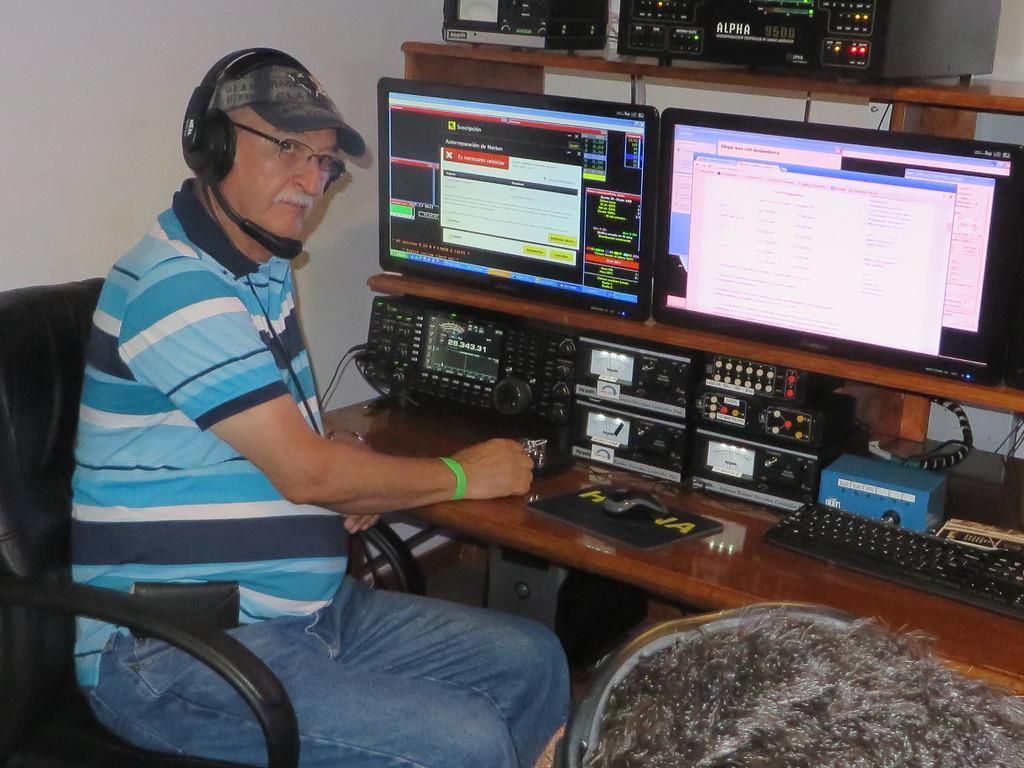Can you describe this image briefly? In the image there is a man sitting on a chair and wearing a headset, in front of him there is a table and on the table there are some equipment, monitors and other gadgets. In the background there is a wall. 